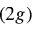<formula> <loc_0><loc_0><loc_500><loc_500>( 2 g )</formula> 